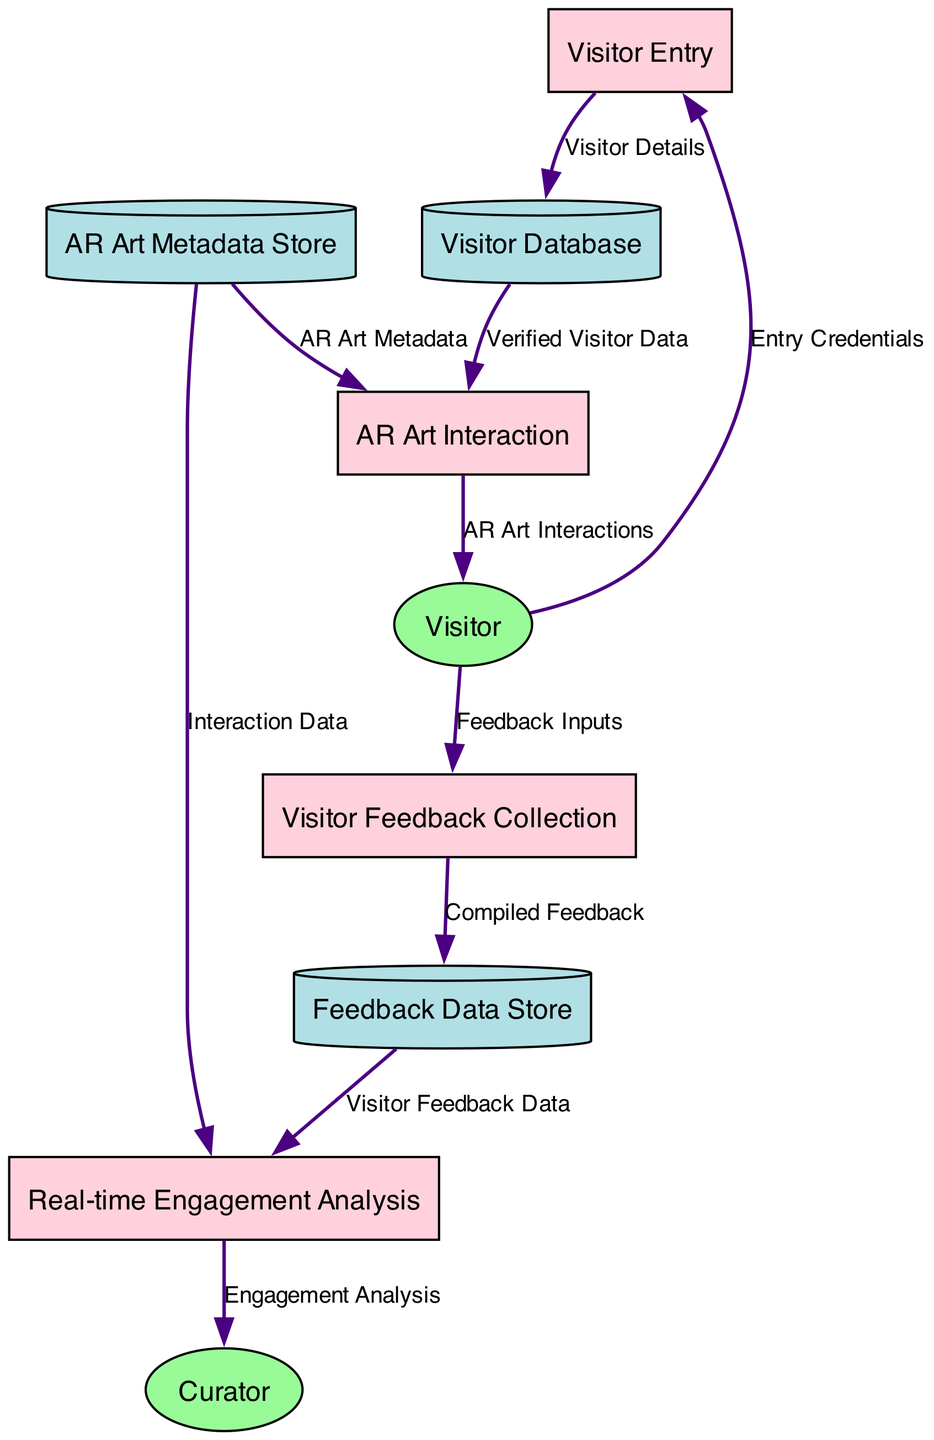What is the first process in the diagram? The first process listed in the diagram is "Visitor Entry," identified by the ID P1. This process handles visitor entry and credential verification.
Answer: Visitor Entry How many processes are represented in the diagram? There are four processes detailed in the diagram: Visitor Entry, AR Art Interaction, Visitor Feedback Collection, and Real-time Engagement Analysis.
Answer: Four Which external entity interacts with the Visitor Feedback Collection process? The entity that provides feedback inputs to the Visitor Feedback Collection process (P3) is the Visitor (E1). This relationship indicates that visitors input their feedback directly.
Answer: Visitor What data flow connects the Visitor Feedback Collection process to the Feedback Data Store? The data flow from the Visitor Feedback Collection process (P3) to the Feedback Data Store (D3) is labeled "Compiled Feedback," indicating that the feedback collected is stored in that data store.
Answer: Compiled Feedback What type of data does the AR Art Interaction process utilize from the AR Art Metadata Store? The AR Art Interaction process (P2) utilizes "AR Art Metadata," which includes descriptions and interactive elements necessary for engaging with the AR art pieces.
Answer: AR Art Metadata Which entity analyzes engagement data in real-time? The entity responsible for analyzing engagement metrics and feedback in real-time is the Curator (E2), who uses data compiled from both visitor interactions and feedback.
Answer: Curator What is the data flow between the Visitor Database and the AR Art Interaction process? The data flow from the Visitor Database (D1) to the AR Art Interaction process (P2) is labeled "Verified Visitor Data," meaning that verified information about visitors is passed to facilitate their interaction with art.
Answer: Verified Visitor Data How many data stores are present in the diagram? There are three data stores represented in the diagram: Visitor Database, AR Art Metadata Store, and Feedback Data Store.
Answer: Three What data does the Real-time Engagement Analysis process receive from the Feedback Data Store? The Real-time Engagement Analysis process (P4) receives "Visitor Feedback Data" from the Feedback Data Store (D3), allowing it to analyze engagement patterns.
Answer: Visitor Feedback Data 